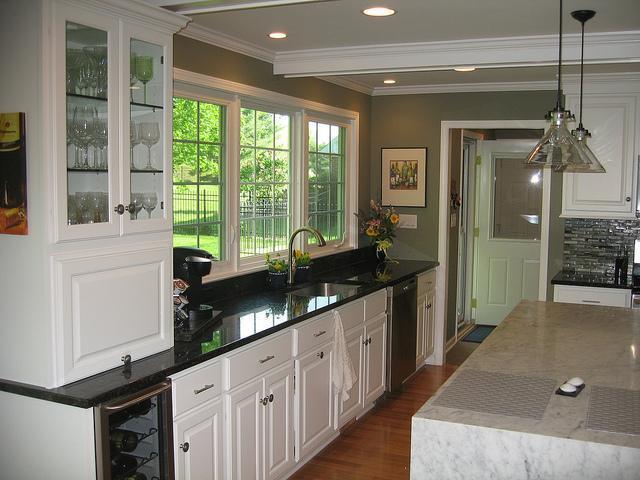How many people are holding a guitar?
Give a very brief answer. 0. 